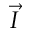<formula> <loc_0><loc_0><loc_500><loc_500>\vec { I }</formula> 